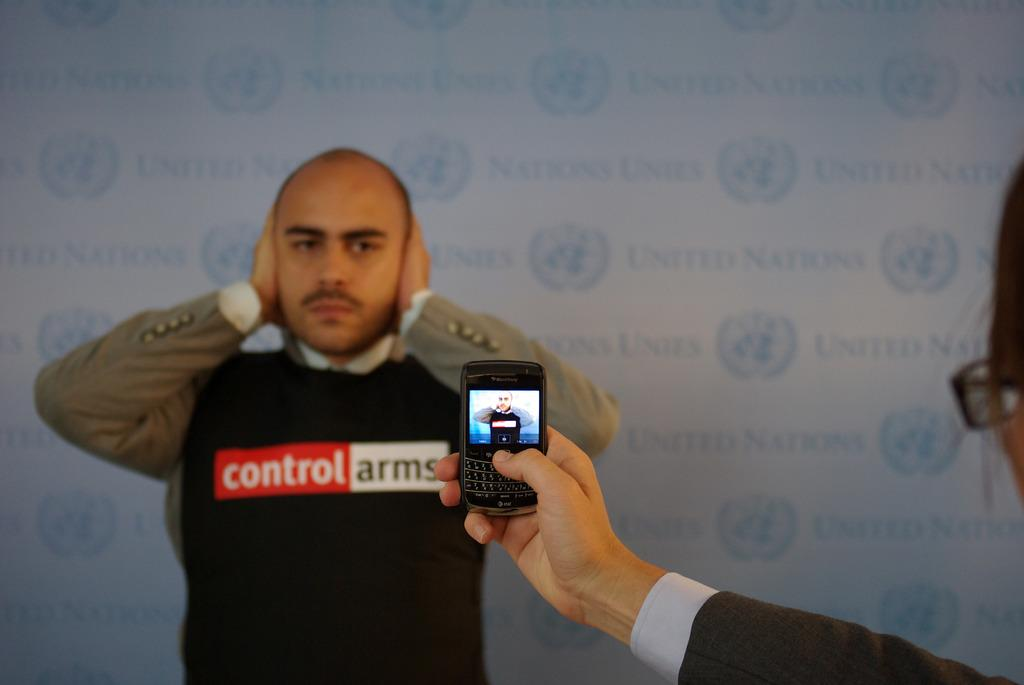Who is the main subject in the image? There is a woman in the image. What is the woman holding in the image? The woman is holding a mobile. Can you describe the background of the image? There is a man standing in the background of the image, and there is a wall visible in the background. What is the woman's tendency to waste resources in the image? There is no information about the woman's tendency to waste resources in the image. 